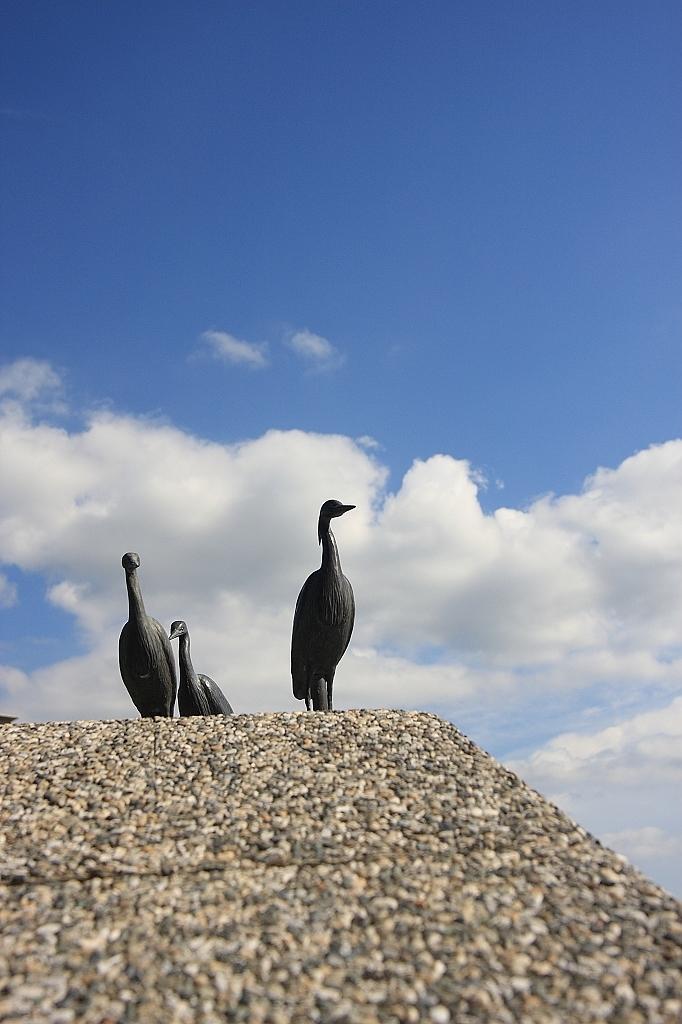Describe this image in one or two sentences. In this picture we can see the birds standing on the ground. At the bottom we can see tiles. At the top we can see sky and clouds. 